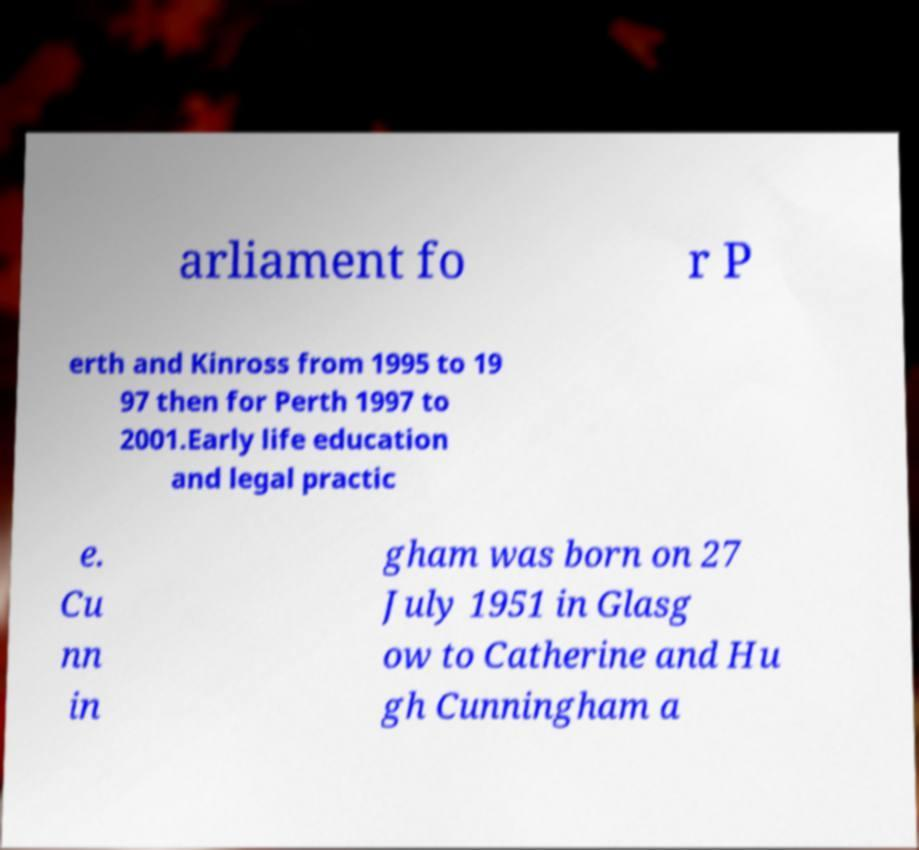There's text embedded in this image that I need extracted. Can you transcribe it verbatim? arliament fo r P erth and Kinross from 1995 to 19 97 then for Perth 1997 to 2001.Early life education and legal practic e. Cu nn in gham was born on 27 July 1951 in Glasg ow to Catherine and Hu gh Cunningham a 